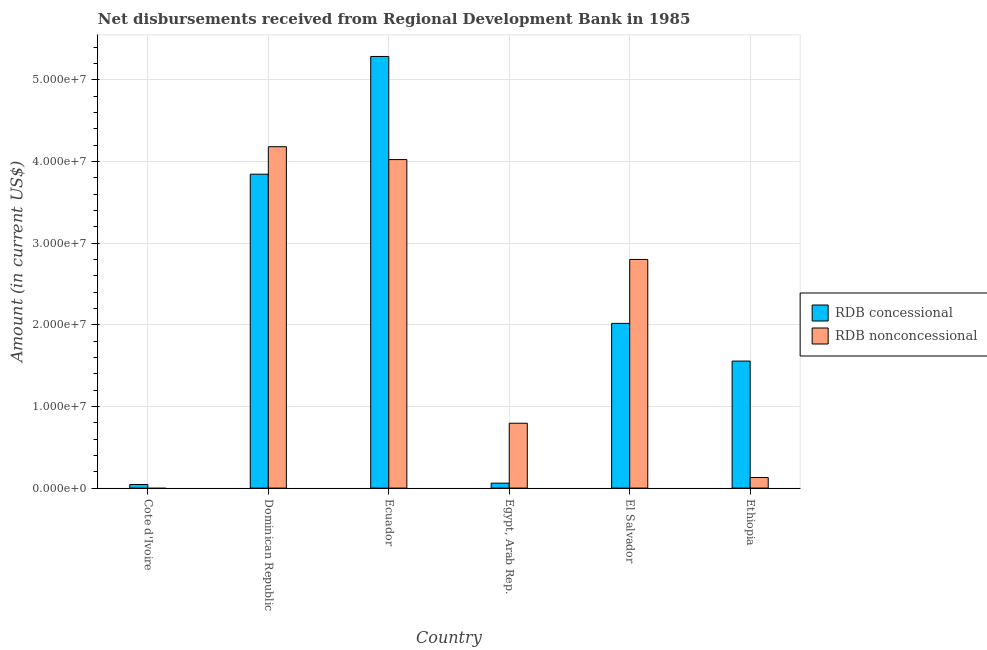Are the number of bars per tick equal to the number of legend labels?
Your response must be concise. No. What is the label of the 5th group of bars from the left?
Offer a terse response. El Salvador. In how many cases, is the number of bars for a given country not equal to the number of legend labels?
Provide a succinct answer. 1. What is the net non concessional disbursements from rdb in Egypt, Arab Rep.?
Your answer should be compact. 7.95e+06. Across all countries, what is the maximum net concessional disbursements from rdb?
Give a very brief answer. 5.29e+07. In which country was the net non concessional disbursements from rdb maximum?
Keep it short and to the point. Dominican Republic. What is the total net concessional disbursements from rdb in the graph?
Give a very brief answer. 1.28e+08. What is the difference between the net concessional disbursements from rdb in Cote d'Ivoire and that in Ethiopia?
Your answer should be compact. -1.51e+07. What is the difference between the net concessional disbursements from rdb in Cote d'Ivoire and the net non concessional disbursements from rdb in Egypt, Arab Rep.?
Your response must be concise. -7.50e+06. What is the average net non concessional disbursements from rdb per country?
Offer a very short reply. 1.99e+07. What is the difference between the net concessional disbursements from rdb and net non concessional disbursements from rdb in Ethiopia?
Provide a short and direct response. 1.43e+07. What is the ratio of the net concessional disbursements from rdb in Ecuador to that in Egypt, Arab Rep.?
Your answer should be compact. 87.25. Is the net concessional disbursements from rdb in Cote d'Ivoire less than that in Ecuador?
Your answer should be very brief. Yes. Is the difference between the net non concessional disbursements from rdb in Dominican Republic and Ethiopia greater than the difference between the net concessional disbursements from rdb in Dominican Republic and Ethiopia?
Your answer should be very brief. Yes. What is the difference between the highest and the second highest net concessional disbursements from rdb?
Offer a terse response. 1.44e+07. What is the difference between the highest and the lowest net non concessional disbursements from rdb?
Keep it short and to the point. 4.18e+07. In how many countries, is the net non concessional disbursements from rdb greater than the average net non concessional disbursements from rdb taken over all countries?
Keep it short and to the point. 3. Is the sum of the net non concessional disbursements from rdb in Dominican Republic and Ecuador greater than the maximum net concessional disbursements from rdb across all countries?
Provide a short and direct response. Yes. Are all the bars in the graph horizontal?
Give a very brief answer. No. How are the legend labels stacked?
Your response must be concise. Vertical. What is the title of the graph?
Ensure brevity in your answer.  Net disbursements received from Regional Development Bank in 1985. What is the label or title of the X-axis?
Keep it short and to the point. Country. What is the Amount (in current US$) of RDB concessional in Cote d'Ivoire?
Ensure brevity in your answer.  4.43e+05. What is the Amount (in current US$) in RDB concessional in Dominican Republic?
Offer a terse response. 3.85e+07. What is the Amount (in current US$) of RDB nonconcessional in Dominican Republic?
Your answer should be very brief. 4.18e+07. What is the Amount (in current US$) in RDB concessional in Ecuador?
Your answer should be compact. 5.29e+07. What is the Amount (in current US$) in RDB nonconcessional in Ecuador?
Offer a very short reply. 4.02e+07. What is the Amount (in current US$) of RDB concessional in Egypt, Arab Rep.?
Make the answer very short. 6.06e+05. What is the Amount (in current US$) of RDB nonconcessional in Egypt, Arab Rep.?
Offer a very short reply. 7.95e+06. What is the Amount (in current US$) of RDB concessional in El Salvador?
Offer a very short reply. 2.02e+07. What is the Amount (in current US$) of RDB nonconcessional in El Salvador?
Your response must be concise. 2.80e+07. What is the Amount (in current US$) in RDB concessional in Ethiopia?
Your response must be concise. 1.56e+07. What is the Amount (in current US$) in RDB nonconcessional in Ethiopia?
Ensure brevity in your answer.  1.30e+06. Across all countries, what is the maximum Amount (in current US$) in RDB concessional?
Offer a very short reply. 5.29e+07. Across all countries, what is the maximum Amount (in current US$) of RDB nonconcessional?
Make the answer very short. 4.18e+07. Across all countries, what is the minimum Amount (in current US$) in RDB concessional?
Give a very brief answer. 4.43e+05. Across all countries, what is the minimum Amount (in current US$) of RDB nonconcessional?
Ensure brevity in your answer.  0. What is the total Amount (in current US$) in RDB concessional in the graph?
Ensure brevity in your answer.  1.28e+08. What is the total Amount (in current US$) of RDB nonconcessional in the graph?
Your answer should be compact. 1.19e+08. What is the difference between the Amount (in current US$) of RDB concessional in Cote d'Ivoire and that in Dominican Republic?
Make the answer very short. -3.80e+07. What is the difference between the Amount (in current US$) in RDB concessional in Cote d'Ivoire and that in Ecuador?
Your answer should be compact. -5.24e+07. What is the difference between the Amount (in current US$) of RDB concessional in Cote d'Ivoire and that in Egypt, Arab Rep.?
Keep it short and to the point. -1.63e+05. What is the difference between the Amount (in current US$) of RDB concessional in Cote d'Ivoire and that in El Salvador?
Provide a short and direct response. -1.97e+07. What is the difference between the Amount (in current US$) of RDB concessional in Cote d'Ivoire and that in Ethiopia?
Your answer should be compact. -1.51e+07. What is the difference between the Amount (in current US$) of RDB concessional in Dominican Republic and that in Ecuador?
Your answer should be compact. -1.44e+07. What is the difference between the Amount (in current US$) in RDB nonconcessional in Dominican Republic and that in Ecuador?
Offer a terse response. 1.58e+06. What is the difference between the Amount (in current US$) of RDB concessional in Dominican Republic and that in Egypt, Arab Rep.?
Keep it short and to the point. 3.78e+07. What is the difference between the Amount (in current US$) of RDB nonconcessional in Dominican Republic and that in Egypt, Arab Rep.?
Provide a succinct answer. 3.39e+07. What is the difference between the Amount (in current US$) of RDB concessional in Dominican Republic and that in El Salvador?
Provide a succinct answer. 1.83e+07. What is the difference between the Amount (in current US$) of RDB nonconcessional in Dominican Republic and that in El Salvador?
Keep it short and to the point. 1.38e+07. What is the difference between the Amount (in current US$) of RDB concessional in Dominican Republic and that in Ethiopia?
Your answer should be very brief. 2.29e+07. What is the difference between the Amount (in current US$) in RDB nonconcessional in Dominican Republic and that in Ethiopia?
Make the answer very short. 4.05e+07. What is the difference between the Amount (in current US$) in RDB concessional in Ecuador and that in Egypt, Arab Rep.?
Your answer should be very brief. 5.23e+07. What is the difference between the Amount (in current US$) of RDB nonconcessional in Ecuador and that in Egypt, Arab Rep.?
Your answer should be very brief. 3.23e+07. What is the difference between the Amount (in current US$) in RDB concessional in Ecuador and that in El Salvador?
Your response must be concise. 3.27e+07. What is the difference between the Amount (in current US$) of RDB nonconcessional in Ecuador and that in El Salvador?
Provide a short and direct response. 1.22e+07. What is the difference between the Amount (in current US$) of RDB concessional in Ecuador and that in Ethiopia?
Make the answer very short. 3.73e+07. What is the difference between the Amount (in current US$) of RDB nonconcessional in Ecuador and that in Ethiopia?
Make the answer very short. 3.89e+07. What is the difference between the Amount (in current US$) in RDB concessional in Egypt, Arab Rep. and that in El Salvador?
Provide a short and direct response. -1.96e+07. What is the difference between the Amount (in current US$) in RDB nonconcessional in Egypt, Arab Rep. and that in El Salvador?
Ensure brevity in your answer.  -2.01e+07. What is the difference between the Amount (in current US$) of RDB concessional in Egypt, Arab Rep. and that in Ethiopia?
Your answer should be compact. -1.50e+07. What is the difference between the Amount (in current US$) in RDB nonconcessional in Egypt, Arab Rep. and that in Ethiopia?
Provide a short and direct response. 6.65e+06. What is the difference between the Amount (in current US$) of RDB concessional in El Salvador and that in Ethiopia?
Provide a short and direct response. 4.62e+06. What is the difference between the Amount (in current US$) in RDB nonconcessional in El Salvador and that in Ethiopia?
Your answer should be compact. 2.67e+07. What is the difference between the Amount (in current US$) in RDB concessional in Cote d'Ivoire and the Amount (in current US$) in RDB nonconcessional in Dominican Republic?
Give a very brief answer. -4.14e+07. What is the difference between the Amount (in current US$) in RDB concessional in Cote d'Ivoire and the Amount (in current US$) in RDB nonconcessional in Ecuador?
Your response must be concise. -3.98e+07. What is the difference between the Amount (in current US$) of RDB concessional in Cote d'Ivoire and the Amount (in current US$) of RDB nonconcessional in Egypt, Arab Rep.?
Ensure brevity in your answer.  -7.50e+06. What is the difference between the Amount (in current US$) of RDB concessional in Cote d'Ivoire and the Amount (in current US$) of RDB nonconcessional in El Salvador?
Offer a very short reply. -2.76e+07. What is the difference between the Amount (in current US$) in RDB concessional in Cote d'Ivoire and the Amount (in current US$) in RDB nonconcessional in Ethiopia?
Offer a very short reply. -8.55e+05. What is the difference between the Amount (in current US$) in RDB concessional in Dominican Republic and the Amount (in current US$) in RDB nonconcessional in Ecuador?
Make the answer very short. -1.79e+06. What is the difference between the Amount (in current US$) in RDB concessional in Dominican Republic and the Amount (in current US$) in RDB nonconcessional in Egypt, Arab Rep.?
Your answer should be compact. 3.05e+07. What is the difference between the Amount (in current US$) of RDB concessional in Dominican Republic and the Amount (in current US$) of RDB nonconcessional in El Salvador?
Your answer should be compact. 1.04e+07. What is the difference between the Amount (in current US$) in RDB concessional in Dominican Republic and the Amount (in current US$) in RDB nonconcessional in Ethiopia?
Make the answer very short. 3.72e+07. What is the difference between the Amount (in current US$) in RDB concessional in Ecuador and the Amount (in current US$) in RDB nonconcessional in Egypt, Arab Rep.?
Offer a very short reply. 4.49e+07. What is the difference between the Amount (in current US$) of RDB concessional in Ecuador and the Amount (in current US$) of RDB nonconcessional in El Salvador?
Provide a short and direct response. 2.49e+07. What is the difference between the Amount (in current US$) in RDB concessional in Ecuador and the Amount (in current US$) in RDB nonconcessional in Ethiopia?
Offer a terse response. 5.16e+07. What is the difference between the Amount (in current US$) in RDB concessional in Egypt, Arab Rep. and the Amount (in current US$) in RDB nonconcessional in El Salvador?
Make the answer very short. -2.74e+07. What is the difference between the Amount (in current US$) in RDB concessional in Egypt, Arab Rep. and the Amount (in current US$) in RDB nonconcessional in Ethiopia?
Provide a succinct answer. -6.92e+05. What is the difference between the Amount (in current US$) of RDB concessional in El Salvador and the Amount (in current US$) of RDB nonconcessional in Ethiopia?
Offer a terse response. 1.89e+07. What is the average Amount (in current US$) of RDB concessional per country?
Your response must be concise. 2.14e+07. What is the average Amount (in current US$) in RDB nonconcessional per country?
Make the answer very short. 1.99e+07. What is the difference between the Amount (in current US$) in RDB concessional and Amount (in current US$) in RDB nonconcessional in Dominican Republic?
Give a very brief answer. -3.37e+06. What is the difference between the Amount (in current US$) of RDB concessional and Amount (in current US$) of RDB nonconcessional in Ecuador?
Make the answer very short. 1.26e+07. What is the difference between the Amount (in current US$) in RDB concessional and Amount (in current US$) in RDB nonconcessional in Egypt, Arab Rep.?
Your answer should be compact. -7.34e+06. What is the difference between the Amount (in current US$) in RDB concessional and Amount (in current US$) in RDB nonconcessional in El Salvador?
Provide a succinct answer. -7.83e+06. What is the difference between the Amount (in current US$) of RDB concessional and Amount (in current US$) of RDB nonconcessional in Ethiopia?
Ensure brevity in your answer.  1.43e+07. What is the ratio of the Amount (in current US$) in RDB concessional in Cote d'Ivoire to that in Dominican Republic?
Ensure brevity in your answer.  0.01. What is the ratio of the Amount (in current US$) of RDB concessional in Cote d'Ivoire to that in Ecuador?
Keep it short and to the point. 0.01. What is the ratio of the Amount (in current US$) of RDB concessional in Cote d'Ivoire to that in Egypt, Arab Rep.?
Your answer should be very brief. 0.73. What is the ratio of the Amount (in current US$) of RDB concessional in Cote d'Ivoire to that in El Salvador?
Ensure brevity in your answer.  0.02. What is the ratio of the Amount (in current US$) of RDB concessional in Cote d'Ivoire to that in Ethiopia?
Offer a very short reply. 0.03. What is the ratio of the Amount (in current US$) in RDB concessional in Dominican Republic to that in Ecuador?
Your answer should be compact. 0.73. What is the ratio of the Amount (in current US$) of RDB nonconcessional in Dominican Republic to that in Ecuador?
Keep it short and to the point. 1.04. What is the ratio of the Amount (in current US$) of RDB concessional in Dominican Republic to that in Egypt, Arab Rep.?
Your answer should be compact. 63.45. What is the ratio of the Amount (in current US$) of RDB nonconcessional in Dominican Republic to that in Egypt, Arab Rep.?
Your answer should be compact. 5.26. What is the ratio of the Amount (in current US$) in RDB concessional in Dominican Republic to that in El Salvador?
Offer a very short reply. 1.91. What is the ratio of the Amount (in current US$) in RDB nonconcessional in Dominican Republic to that in El Salvador?
Your response must be concise. 1.49. What is the ratio of the Amount (in current US$) in RDB concessional in Dominican Republic to that in Ethiopia?
Provide a short and direct response. 2.47. What is the ratio of the Amount (in current US$) of RDB nonconcessional in Dominican Republic to that in Ethiopia?
Your answer should be compact. 32.22. What is the ratio of the Amount (in current US$) of RDB concessional in Ecuador to that in Egypt, Arab Rep.?
Make the answer very short. 87.25. What is the ratio of the Amount (in current US$) in RDB nonconcessional in Ecuador to that in Egypt, Arab Rep.?
Your answer should be compact. 5.06. What is the ratio of the Amount (in current US$) of RDB concessional in Ecuador to that in El Salvador?
Your response must be concise. 2.62. What is the ratio of the Amount (in current US$) of RDB nonconcessional in Ecuador to that in El Salvador?
Give a very brief answer. 1.44. What is the ratio of the Amount (in current US$) of RDB concessional in Ecuador to that in Ethiopia?
Ensure brevity in your answer.  3.4. What is the ratio of the Amount (in current US$) in RDB nonconcessional in Ecuador to that in Ethiopia?
Your answer should be very brief. 31. What is the ratio of the Amount (in current US$) of RDB concessional in Egypt, Arab Rep. to that in El Salvador?
Offer a terse response. 0.03. What is the ratio of the Amount (in current US$) of RDB nonconcessional in Egypt, Arab Rep. to that in El Salvador?
Provide a short and direct response. 0.28. What is the ratio of the Amount (in current US$) of RDB concessional in Egypt, Arab Rep. to that in Ethiopia?
Keep it short and to the point. 0.04. What is the ratio of the Amount (in current US$) of RDB nonconcessional in Egypt, Arab Rep. to that in Ethiopia?
Make the answer very short. 6.12. What is the ratio of the Amount (in current US$) in RDB concessional in El Salvador to that in Ethiopia?
Your response must be concise. 1.3. What is the ratio of the Amount (in current US$) in RDB nonconcessional in El Salvador to that in Ethiopia?
Keep it short and to the point. 21.58. What is the difference between the highest and the second highest Amount (in current US$) of RDB concessional?
Provide a short and direct response. 1.44e+07. What is the difference between the highest and the second highest Amount (in current US$) of RDB nonconcessional?
Keep it short and to the point. 1.58e+06. What is the difference between the highest and the lowest Amount (in current US$) in RDB concessional?
Give a very brief answer. 5.24e+07. What is the difference between the highest and the lowest Amount (in current US$) in RDB nonconcessional?
Give a very brief answer. 4.18e+07. 